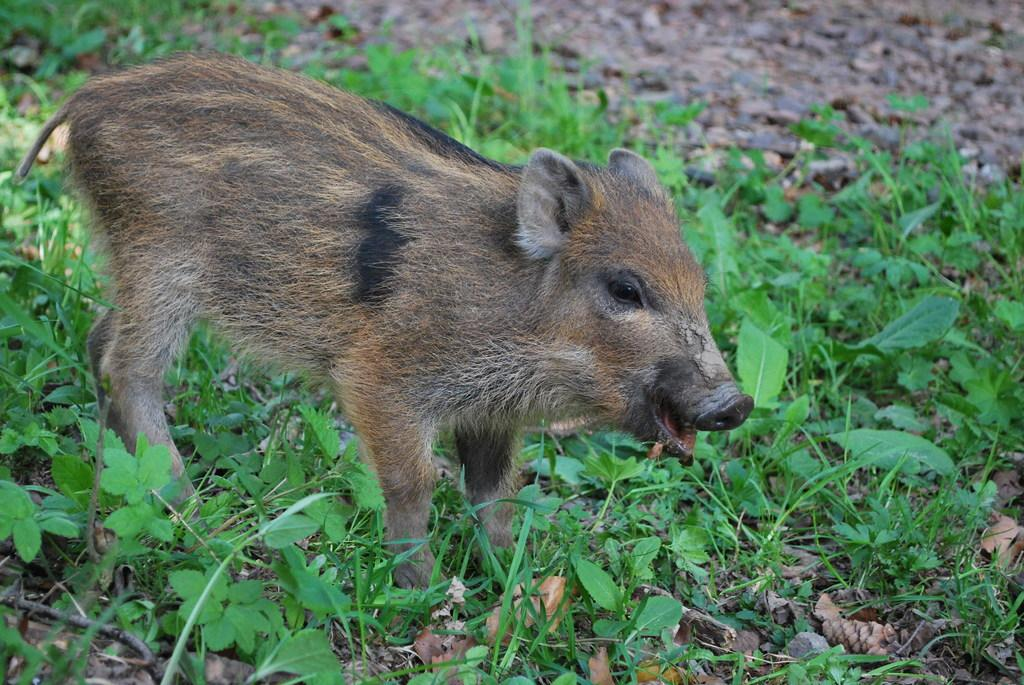What type of animal is on the ground in the image? The specific type of animal cannot be determined from the provided facts. What can be seen on the right side of the image? There are plants on the right side of the image. What type of vegetation is visible in the image? Grass is visible in the image. What is your brother doing on the floor in the north side of the image? There is no mention of a brother or a floor in the image, and the north side is not relevant to the provided facts. 